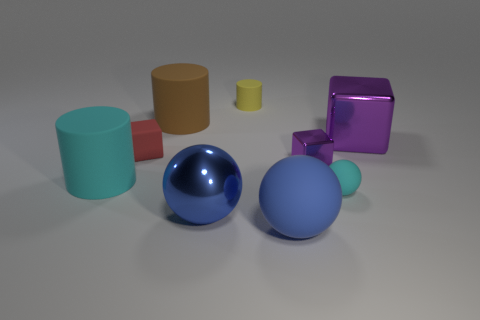Subtract all cylinders. How many objects are left? 6 Add 6 big shiny balls. How many big shiny balls exist? 7 Subtract 0 yellow spheres. How many objects are left? 9 Subtract all tiny cyan spheres. Subtract all big purple metallic cubes. How many objects are left? 7 Add 4 rubber cylinders. How many rubber cylinders are left? 7 